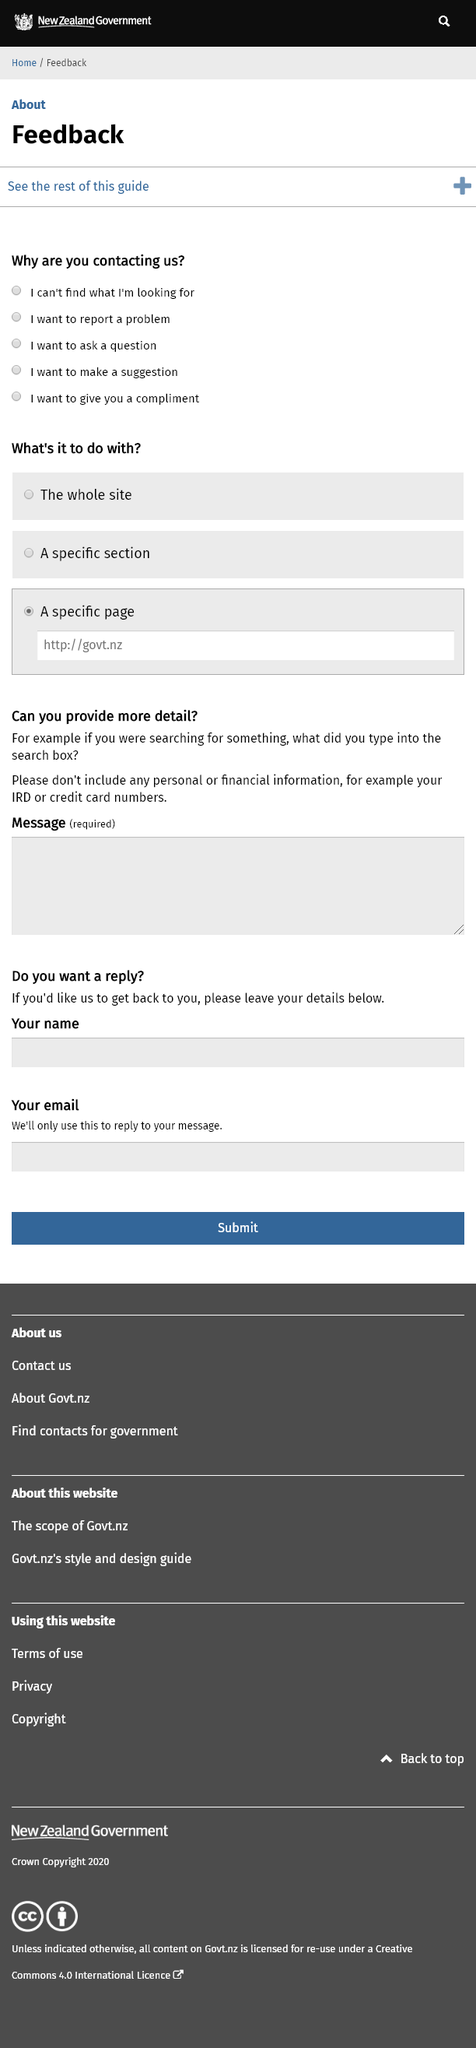Highlight a few significant elements in this photo. It is an example of feedback when a person desires to offer a recommendation or suggestion. Wanting to ask a question is an example of feedback. Yes, it is an example of feedback when individuals want to report problems. 